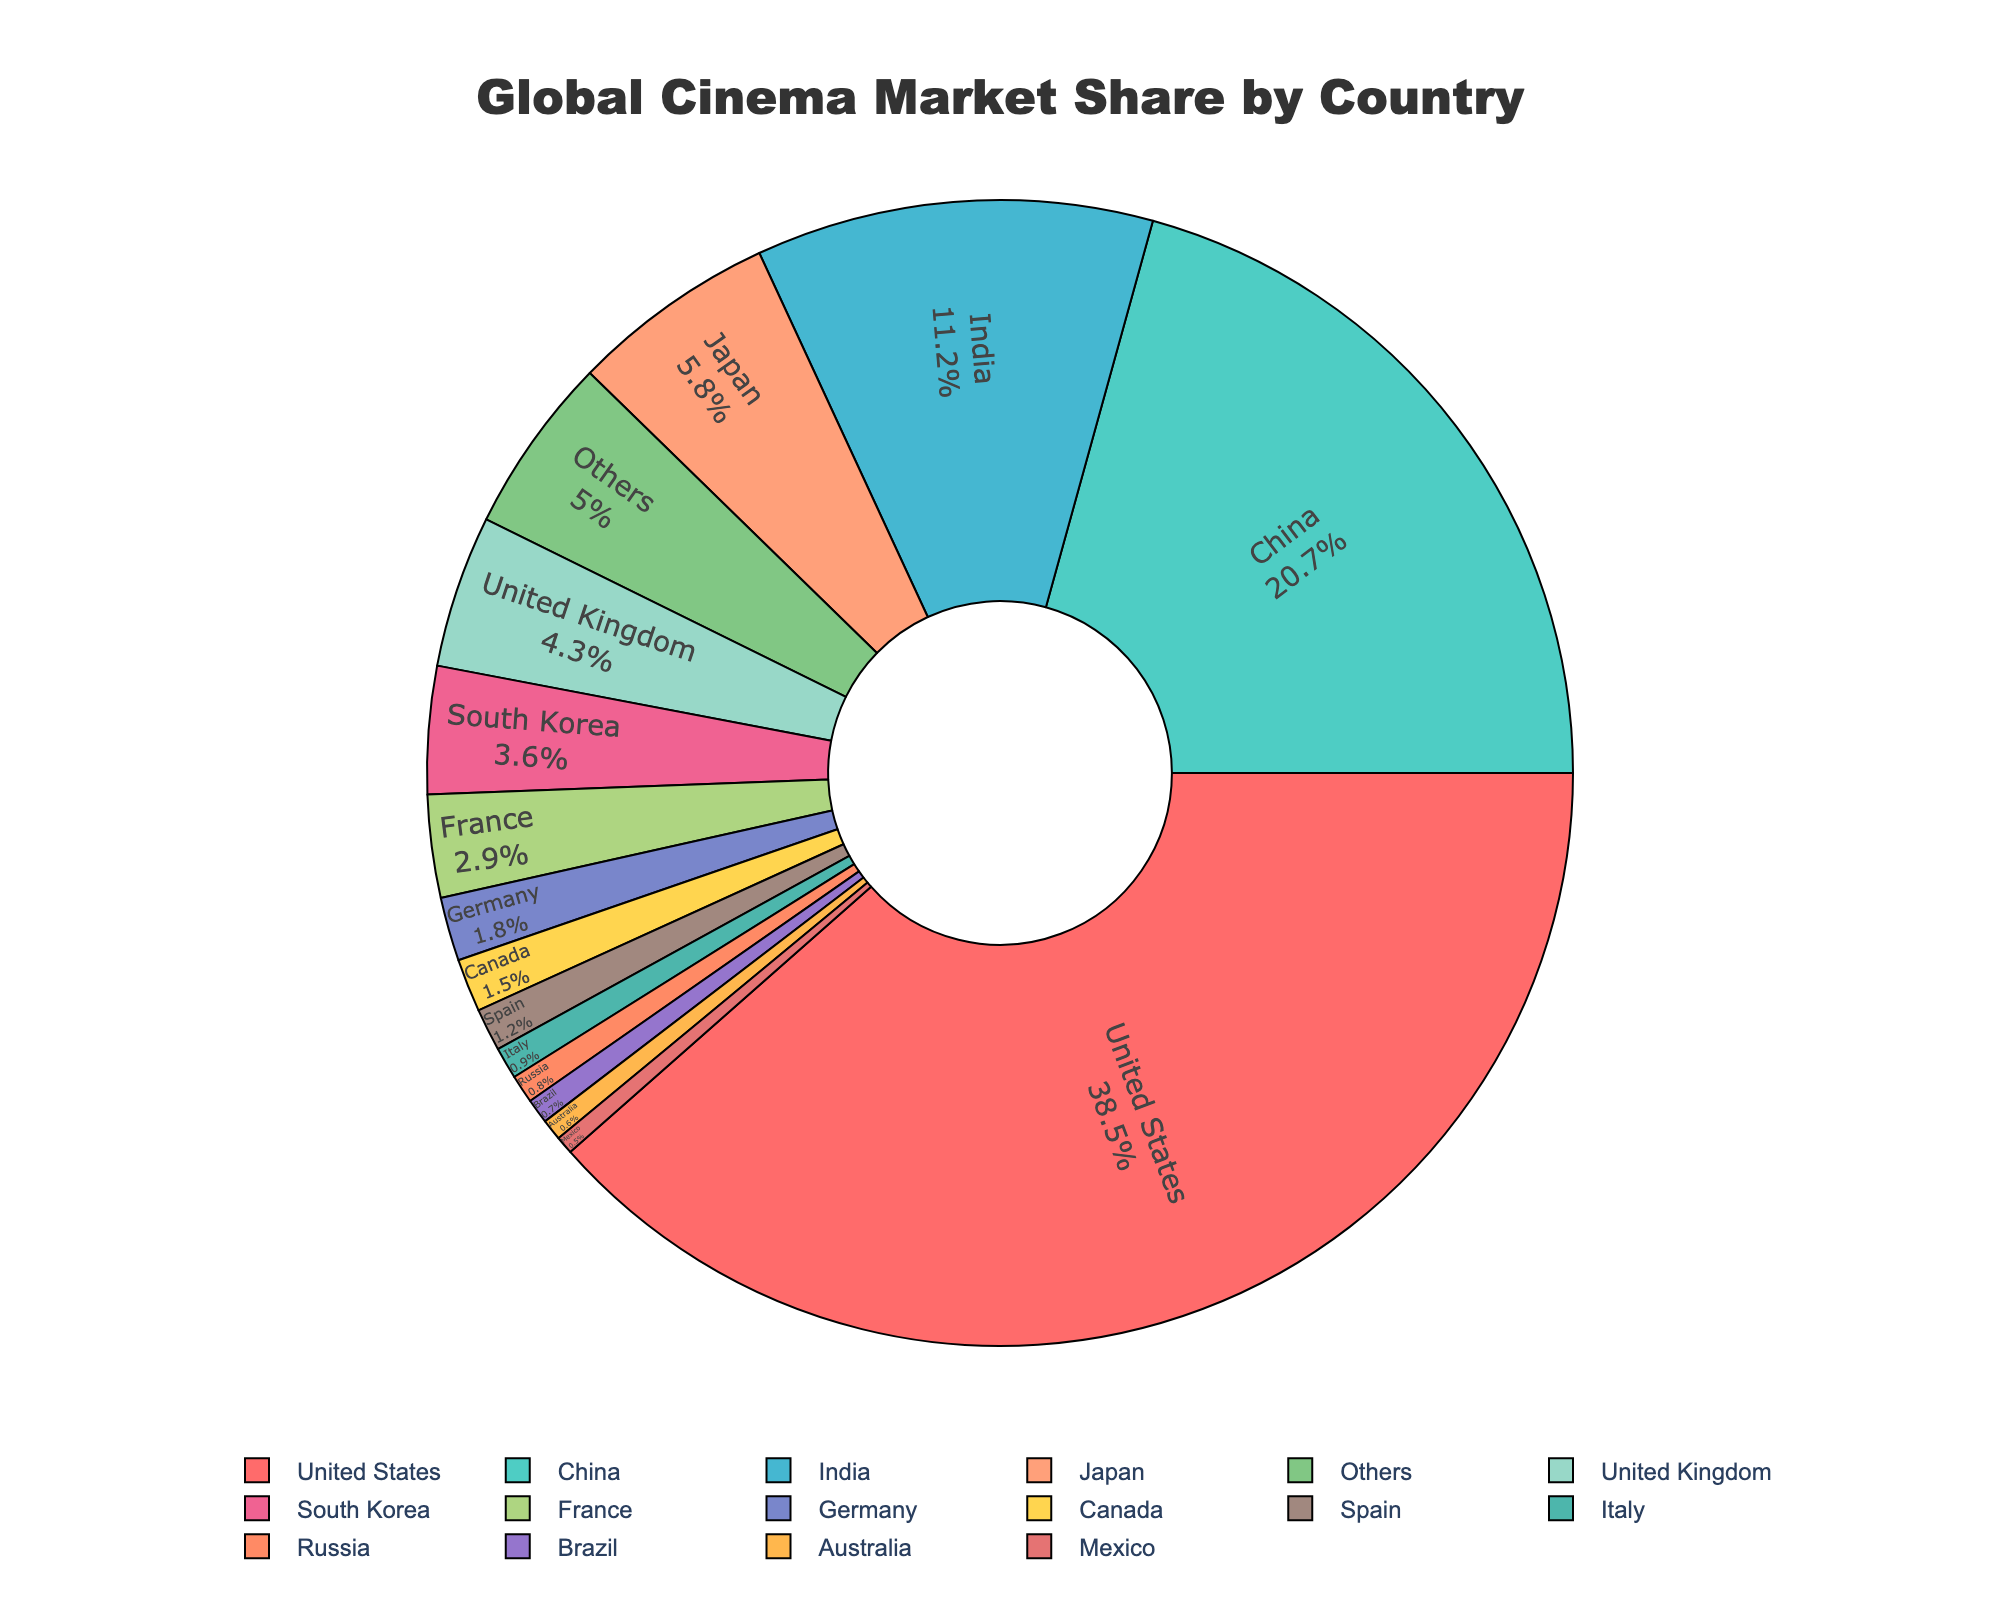Which country has the highest market share in global cinema? According to the pie chart, the United States has the largest segment of the pie, indicating the highest share.
Answer: United States Which two countries together account for more than half of the global cinema market? Adding the shares of the United States (38.5%) and China (20.7%) results in 59.2%, which is more than 50%.
Answer: United States and China Which country has a smaller market share: Japan or the United Kingdom? The chart shows that Japan has 5.8%, while the United Kingdom has 4.3%. Since 4.3% is less than 5.8%, the UK has a smaller share.
Answer: United Kingdom What is the combined market share of the countries with less than 1% each? Summing the shares of Italy (0.9%), Russia (0.8%), Brazil (0.7%), Australia (0.6%), and Mexico (0.5%), we get 3.5%.
Answer: 3.5% Rank the top three countries by their market share in global cinema. The chart shows the top three segments by size: United States (38.5%), China (20.7%), and India (11.2%). Thus, the rank in descending order is the United States, China, and India.
Answer: United States, China, India What is the percentage difference in market share between China and India? Subtracting India's share (11.2%) from China's share (20.7%) results in a difference of 9.5%.
Answer: 9.5% Which country has a market share closest to 5%? The chart shows that Japan has 5.8%, which is the closest to 5%.
Answer: Japan How many countries have a market share greater than 10%? Both the United States (38.5%) and China (20.7%) have shares greater than 10%. India has 11.2%, which is also above 10%. Hence, there are three countries.
Answer: 3 What is the total market share of European countries listed? Summing the shares for United Kingdom (4.3%), France (2.9%), Germany (1.8%), Spain (1.2%), and Italy (0.9%) equals 11.1%.
Answer: 11.1% Which color represents the country with the lowest market share, and what is that share? According to the color pattern descriptions, Mexico is the smallest segment (0.5%), and the color code description, while not directly stated, can be inferred visually by its smallest segment in the pie chart.
Answer: 0.5% 